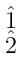Convert formula to latex. <formula><loc_0><loc_0><loc_500><loc_500>\begin{smallmatrix} \hat { 1 } \\ \hat { 2 } \end{smallmatrix}</formula> 